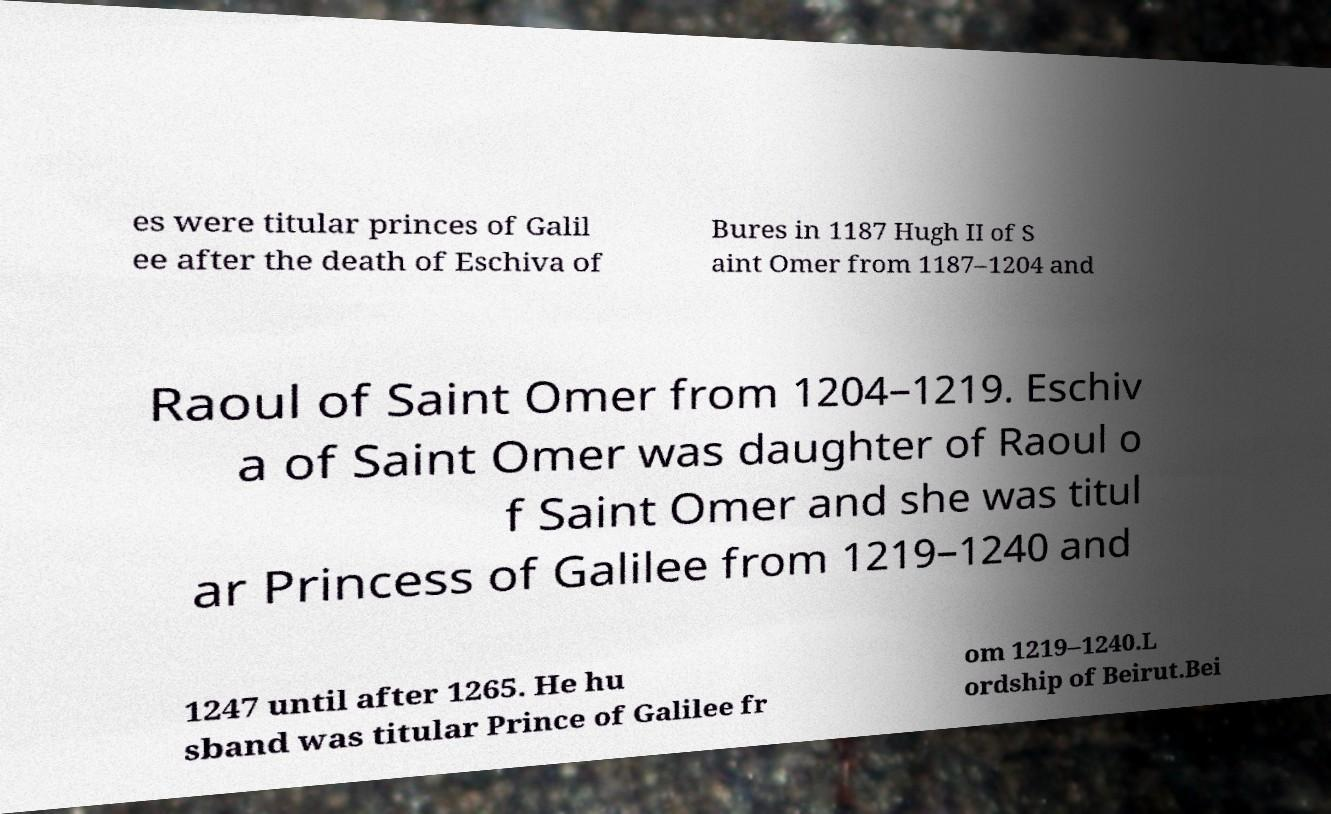For documentation purposes, I need the text within this image transcribed. Could you provide that? es were titular princes of Galil ee after the death of Eschiva of Bures in 1187 Hugh II of S aint Omer from 1187–1204 and Raoul of Saint Omer from 1204–1219. Eschiv a of Saint Omer was daughter of Raoul o f Saint Omer and she was titul ar Princess of Galilee from 1219–1240 and 1247 until after 1265. He hu sband was titular Prince of Galilee fr om 1219–1240.L ordship of Beirut.Bei 